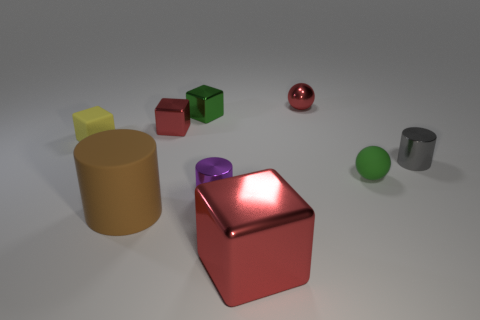Add 1 big blue matte spheres. How many objects exist? 10 Subtract all metal blocks. How many blocks are left? 1 Subtract all red blocks. How many blocks are left? 2 Subtract 2 spheres. How many spheres are left? 0 Subtract all spheres. How many objects are left? 7 Subtract all tiny purple metallic cylinders. Subtract all rubber blocks. How many objects are left? 7 Add 7 metallic cubes. How many metallic cubes are left? 10 Add 1 large blue cylinders. How many large blue cylinders exist? 1 Subtract 0 green cylinders. How many objects are left? 9 Subtract all green spheres. Subtract all blue cylinders. How many spheres are left? 1 